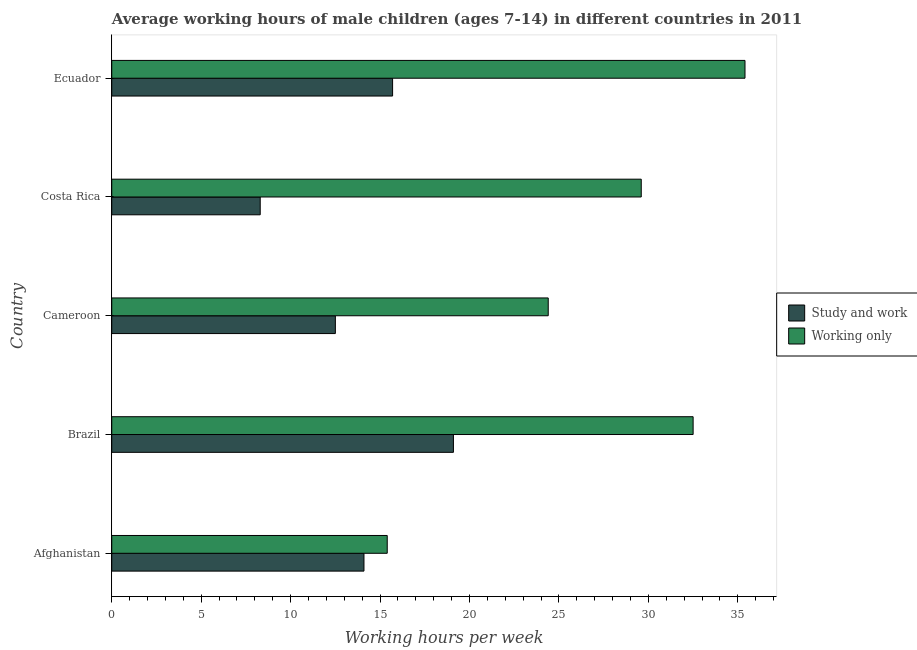What is the label of the 5th group of bars from the top?
Offer a very short reply. Afghanistan. What is the average working hour of children involved in only work in Ecuador?
Offer a very short reply. 35.4. Across all countries, what is the maximum average working hour of children involved in study and work?
Keep it short and to the point. 19.1. Across all countries, what is the minimum average working hour of children involved in study and work?
Provide a short and direct response. 8.3. In which country was the average working hour of children involved in study and work maximum?
Make the answer very short. Brazil. In which country was the average working hour of children involved in only work minimum?
Give a very brief answer. Afghanistan. What is the total average working hour of children involved in study and work in the graph?
Keep it short and to the point. 69.7. What is the difference between the average working hour of children involved in only work in Afghanistan and that in Brazil?
Give a very brief answer. -17.1. What is the average average working hour of children involved in only work per country?
Keep it short and to the point. 27.46. What is the difference between the average working hour of children involved in only work and average working hour of children involved in study and work in Brazil?
Provide a succinct answer. 13.4. What is the ratio of the average working hour of children involved in study and work in Brazil to that in Ecuador?
Offer a very short reply. 1.22. Is the difference between the average working hour of children involved in study and work in Afghanistan and Cameroon greater than the difference between the average working hour of children involved in only work in Afghanistan and Cameroon?
Provide a short and direct response. Yes. What is the difference between the highest and the lowest average working hour of children involved in only work?
Make the answer very short. 20. In how many countries, is the average working hour of children involved in study and work greater than the average average working hour of children involved in study and work taken over all countries?
Provide a succinct answer. 3. Is the sum of the average working hour of children involved in study and work in Afghanistan and Cameroon greater than the maximum average working hour of children involved in only work across all countries?
Your response must be concise. No. What does the 2nd bar from the top in Cameroon represents?
Make the answer very short. Study and work. What does the 1st bar from the bottom in Ecuador represents?
Make the answer very short. Study and work. How many bars are there?
Offer a terse response. 10. How many countries are there in the graph?
Your answer should be very brief. 5. What is the difference between two consecutive major ticks on the X-axis?
Offer a very short reply. 5. Does the graph contain any zero values?
Make the answer very short. No. Where does the legend appear in the graph?
Keep it short and to the point. Center right. How are the legend labels stacked?
Offer a very short reply. Vertical. What is the title of the graph?
Offer a terse response. Average working hours of male children (ages 7-14) in different countries in 2011. What is the label or title of the X-axis?
Offer a very short reply. Working hours per week. What is the Working hours per week of Working only in Afghanistan?
Your response must be concise. 15.4. What is the Working hours per week in Working only in Brazil?
Your answer should be very brief. 32.5. What is the Working hours per week of Study and work in Cameroon?
Your response must be concise. 12.5. What is the Working hours per week of Working only in Cameroon?
Offer a very short reply. 24.4. What is the Working hours per week of Working only in Costa Rica?
Give a very brief answer. 29.6. What is the Working hours per week in Study and work in Ecuador?
Offer a very short reply. 15.7. What is the Working hours per week in Working only in Ecuador?
Offer a very short reply. 35.4. Across all countries, what is the maximum Working hours per week in Study and work?
Offer a terse response. 19.1. Across all countries, what is the maximum Working hours per week of Working only?
Make the answer very short. 35.4. What is the total Working hours per week in Study and work in the graph?
Provide a short and direct response. 69.7. What is the total Working hours per week in Working only in the graph?
Offer a terse response. 137.3. What is the difference between the Working hours per week of Working only in Afghanistan and that in Brazil?
Make the answer very short. -17.1. What is the difference between the Working hours per week in Study and work in Afghanistan and that in Cameroon?
Provide a short and direct response. 1.6. What is the difference between the Working hours per week in Working only in Afghanistan and that in Cameroon?
Keep it short and to the point. -9. What is the difference between the Working hours per week in Study and work in Afghanistan and that in Costa Rica?
Ensure brevity in your answer.  5.8. What is the difference between the Working hours per week of Study and work in Brazil and that in Cameroon?
Provide a short and direct response. 6.6. What is the difference between the Working hours per week of Working only in Brazil and that in Cameroon?
Ensure brevity in your answer.  8.1. What is the difference between the Working hours per week in Study and work in Brazil and that in Costa Rica?
Provide a succinct answer. 10.8. What is the difference between the Working hours per week in Working only in Brazil and that in Costa Rica?
Your answer should be compact. 2.9. What is the difference between the Working hours per week in Study and work in Brazil and that in Ecuador?
Offer a very short reply. 3.4. What is the difference between the Working hours per week of Working only in Brazil and that in Ecuador?
Your response must be concise. -2.9. What is the difference between the Working hours per week of Working only in Cameroon and that in Ecuador?
Ensure brevity in your answer.  -11. What is the difference between the Working hours per week in Study and work in Afghanistan and the Working hours per week in Working only in Brazil?
Provide a succinct answer. -18.4. What is the difference between the Working hours per week in Study and work in Afghanistan and the Working hours per week in Working only in Costa Rica?
Provide a succinct answer. -15.5. What is the difference between the Working hours per week in Study and work in Afghanistan and the Working hours per week in Working only in Ecuador?
Offer a very short reply. -21.3. What is the difference between the Working hours per week of Study and work in Brazil and the Working hours per week of Working only in Costa Rica?
Make the answer very short. -10.5. What is the difference between the Working hours per week of Study and work in Brazil and the Working hours per week of Working only in Ecuador?
Provide a short and direct response. -16.3. What is the difference between the Working hours per week in Study and work in Cameroon and the Working hours per week in Working only in Costa Rica?
Your answer should be very brief. -17.1. What is the difference between the Working hours per week in Study and work in Cameroon and the Working hours per week in Working only in Ecuador?
Provide a succinct answer. -22.9. What is the difference between the Working hours per week of Study and work in Costa Rica and the Working hours per week of Working only in Ecuador?
Make the answer very short. -27.1. What is the average Working hours per week in Study and work per country?
Offer a terse response. 13.94. What is the average Working hours per week of Working only per country?
Keep it short and to the point. 27.46. What is the difference between the Working hours per week in Study and work and Working hours per week in Working only in Brazil?
Provide a succinct answer. -13.4. What is the difference between the Working hours per week of Study and work and Working hours per week of Working only in Cameroon?
Offer a terse response. -11.9. What is the difference between the Working hours per week in Study and work and Working hours per week in Working only in Costa Rica?
Provide a succinct answer. -21.3. What is the difference between the Working hours per week in Study and work and Working hours per week in Working only in Ecuador?
Provide a short and direct response. -19.7. What is the ratio of the Working hours per week in Study and work in Afghanistan to that in Brazil?
Your answer should be very brief. 0.74. What is the ratio of the Working hours per week of Working only in Afghanistan to that in Brazil?
Offer a terse response. 0.47. What is the ratio of the Working hours per week of Study and work in Afghanistan to that in Cameroon?
Your answer should be very brief. 1.13. What is the ratio of the Working hours per week of Working only in Afghanistan to that in Cameroon?
Give a very brief answer. 0.63. What is the ratio of the Working hours per week of Study and work in Afghanistan to that in Costa Rica?
Ensure brevity in your answer.  1.7. What is the ratio of the Working hours per week of Working only in Afghanistan to that in Costa Rica?
Make the answer very short. 0.52. What is the ratio of the Working hours per week of Study and work in Afghanistan to that in Ecuador?
Your answer should be compact. 0.9. What is the ratio of the Working hours per week of Working only in Afghanistan to that in Ecuador?
Keep it short and to the point. 0.43. What is the ratio of the Working hours per week of Study and work in Brazil to that in Cameroon?
Keep it short and to the point. 1.53. What is the ratio of the Working hours per week of Working only in Brazil to that in Cameroon?
Your response must be concise. 1.33. What is the ratio of the Working hours per week of Study and work in Brazil to that in Costa Rica?
Keep it short and to the point. 2.3. What is the ratio of the Working hours per week in Working only in Brazil to that in Costa Rica?
Give a very brief answer. 1.1. What is the ratio of the Working hours per week of Study and work in Brazil to that in Ecuador?
Provide a succinct answer. 1.22. What is the ratio of the Working hours per week of Working only in Brazil to that in Ecuador?
Keep it short and to the point. 0.92. What is the ratio of the Working hours per week of Study and work in Cameroon to that in Costa Rica?
Offer a very short reply. 1.51. What is the ratio of the Working hours per week of Working only in Cameroon to that in Costa Rica?
Your answer should be very brief. 0.82. What is the ratio of the Working hours per week in Study and work in Cameroon to that in Ecuador?
Your answer should be very brief. 0.8. What is the ratio of the Working hours per week of Working only in Cameroon to that in Ecuador?
Your answer should be very brief. 0.69. What is the ratio of the Working hours per week of Study and work in Costa Rica to that in Ecuador?
Provide a short and direct response. 0.53. What is the ratio of the Working hours per week of Working only in Costa Rica to that in Ecuador?
Provide a short and direct response. 0.84. What is the difference between the highest and the second highest Working hours per week in Study and work?
Make the answer very short. 3.4. What is the difference between the highest and the lowest Working hours per week of Study and work?
Make the answer very short. 10.8. What is the difference between the highest and the lowest Working hours per week of Working only?
Provide a succinct answer. 20. 